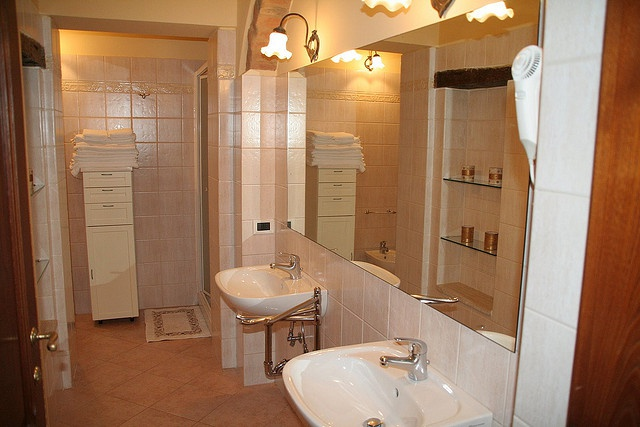Describe the objects in this image and their specific colors. I can see sink in black, tan, lightgray, and darkgray tones, sink in black and tan tones, and hair drier in black, lightgray, darkgray, and tan tones in this image. 